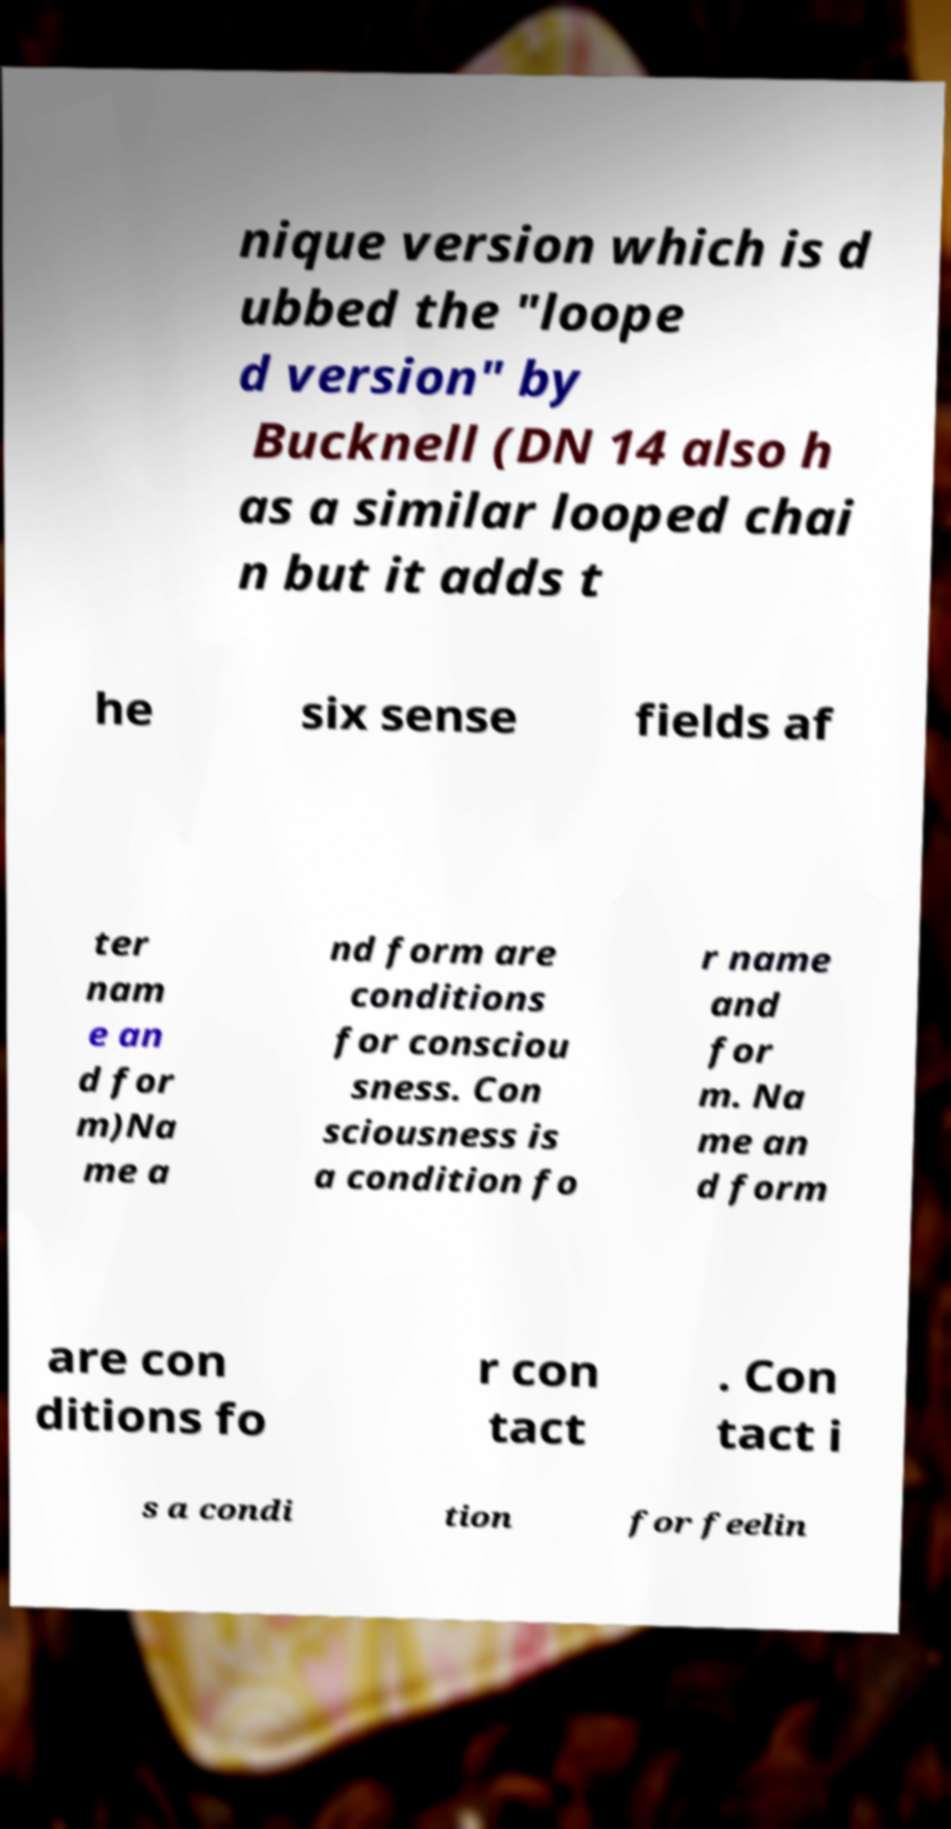What messages or text are displayed in this image? I need them in a readable, typed format. nique version which is d ubbed the "loope d version" by Bucknell (DN 14 also h as a similar looped chai n but it adds t he six sense fields af ter nam e an d for m)Na me a nd form are conditions for consciou sness. Con sciousness is a condition fo r name and for m. Na me an d form are con ditions fo r con tact . Con tact i s a condi tion for feelin 